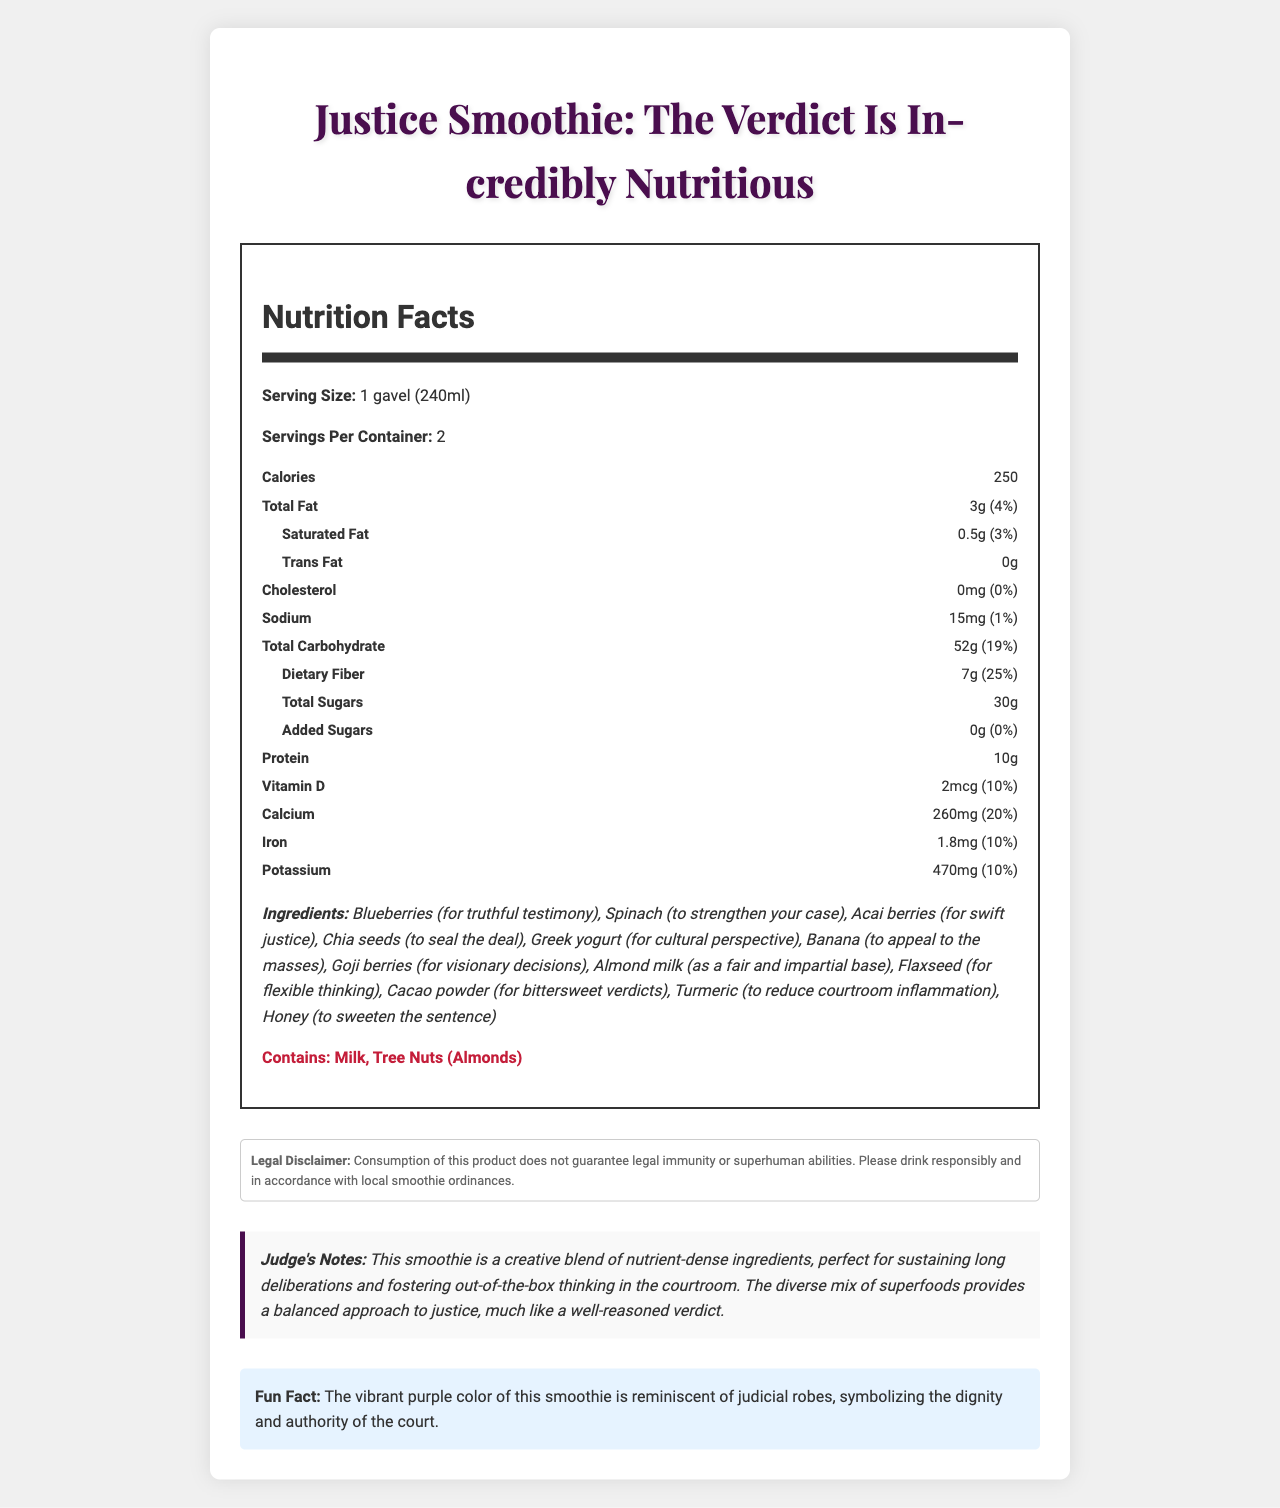How many calories are in one serving of the Justice Smoothie? The document states that there are 250 calories per serving.
Answer: 250 What is the serving size of the Justice Smoothie? The document specifies the serving size as 1 gavel (240ml).
Answer: 1 gavel (240ml) How much total carbohydrate is in one serving of the Justice Smoothie? The nutrition facts list 52g of total carbohydrate per serving.
Answer: 52g Does the Justice Smoothie contain any added sugars? The nutrition facts indicate that there are 0g of added sugars.
Answer: No What are the primary allergens in the Justice Smoothie? The allergen information lists milk and tree nuts (almonds) as the primary allergens.
Answer: Milk, Tree Nuts (Almonds) How much protein does the Justice Smoothie provide in one serving? The nutrition facts label states that there are 10g of protein per serving.
Answer: 10g How much potassium does each serving of the Justice Smoothie contain? The document states that one serving contains 470mg of potassium, which is 10% of the Daily Value.
Answer: 470mg (10% Daily Value) What ingredient in the Justice Smoothie is intended to "reduce courtroom inflammation"? According to the ingredients list, turmeric is included to reduce courtroom inflammation.
Answer: Turmeric Which ingredient is described as adding "bittersweet verdicts" to the Justice Smoothie? A. Blueberries B. Cacao powder C. Goji berries D. Honey Cacao powder is described as contributing "bittersweet verdicts."
Answer: B How much dietary fiber is in the Justice Smoothie per serving? The nutrition facts state that there are 7g of dietary fiber per serving.
Answer: 7g The Justice Smoothie helps foster what type of thinking according to the judge's notes? The judge's notes mention that the smoothie is perfect for fostering out-of-the-box thinking in the courtroom.
Answer: Out-of-the-box thinking What is the fun fact about the Justice Smoothie? This information is found in the "Fun Fact" section.
Answer: The vibrant purple color of this smoothie is reminiscent of judicial robes, symbolizing the dignity and authority of the court. How many servings are there per container of the Justice Smoothie? The document states that there are 2 servings per container.
Answer: 2 Does the Justice Smoothie guarantee legal immunity? The legal disclaimer explicitly states that consumption of this product does not guarantee legal immunity.
Answer: No Which of the following is not an ingredient in the Justice Smoothie? I. Pineapple II. Spinach III. Acai Berries The ingredients list includes spinach and acai berries but not pineapple.
Answer: I. Pineapple Summarize the main idea of the document. The document contains comprehensive details about the Justice Smoothie, including its nutritional value, list of ingredients, allergen information, legal disclaimer, judge's notes, and a fun fact, encapsulating the smoothie’s purpose and benefits.
Answer: The document provides a detailed description of the Justice Smoothie, highlighting its nutritional facts, ingredients, allergens, and some creative notes about its benefits and fun fact. It emphasizes the smoothie’s nutritious composition and its thematic elements related to justice and courtroom-inspired puns. What are the precise amounts of Vitamin D and Iron in the Justice Smoothie? The nutrition facts label lists 2mcg of Vitamin D and 1.8mg of Iron per serving.
Answer: 2mcg of Vitamin D and 1.8mg of Iron Is the Justice Smoothie gluten-free? The document does not provide information regarding the presence or absence of gluten.
Answer: Not enough information 